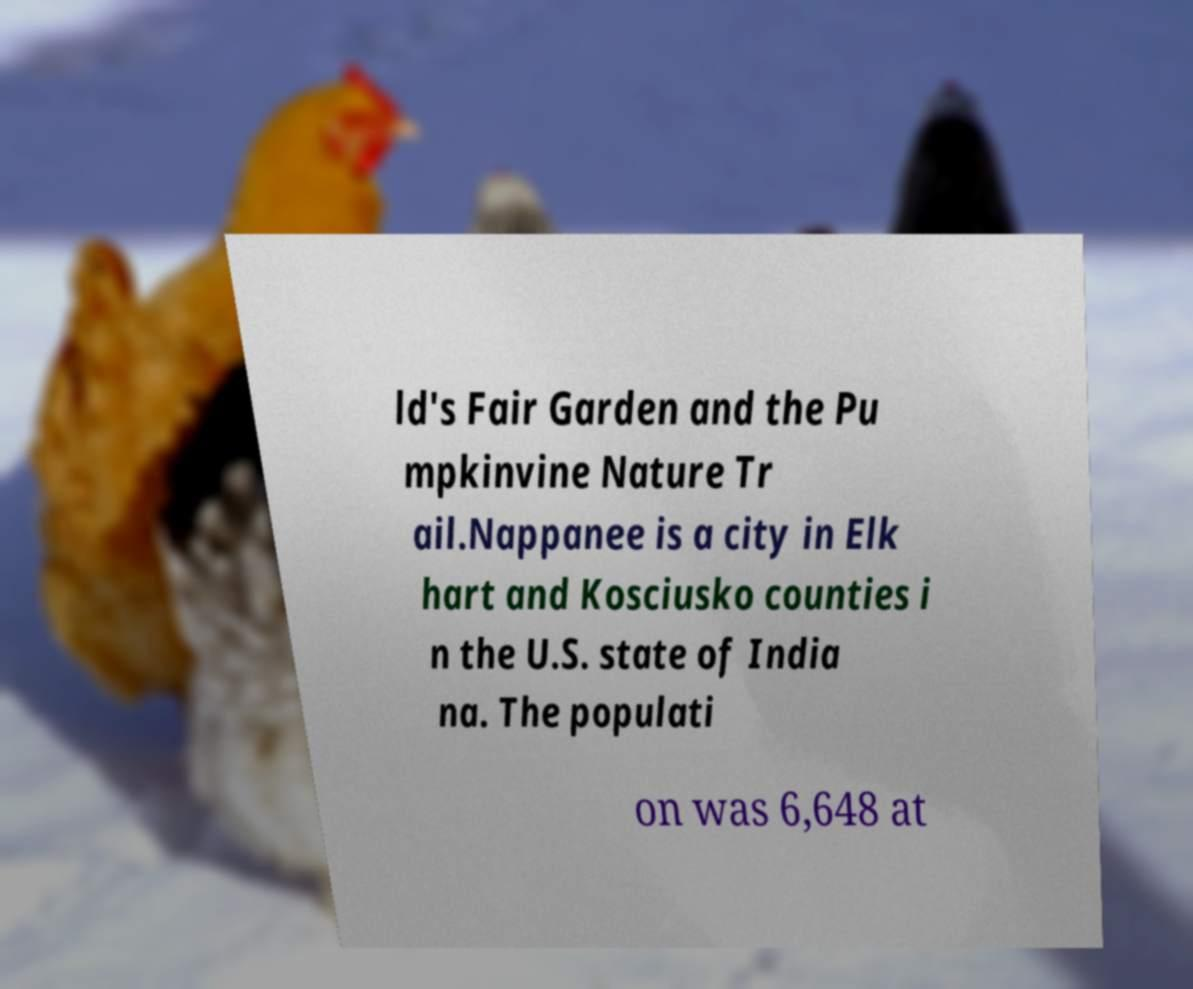Can you read and provide the text displayed in the image?This photo seems to have some interesting text. Can you extract and type it out for me? ld's Fair Garden and the Pu mpkinvine Nature Tr ail.Nappanee is a city in Elk hart and Kosciusko counties i n the U.S. state of India na. The populati on was 6,648 at 